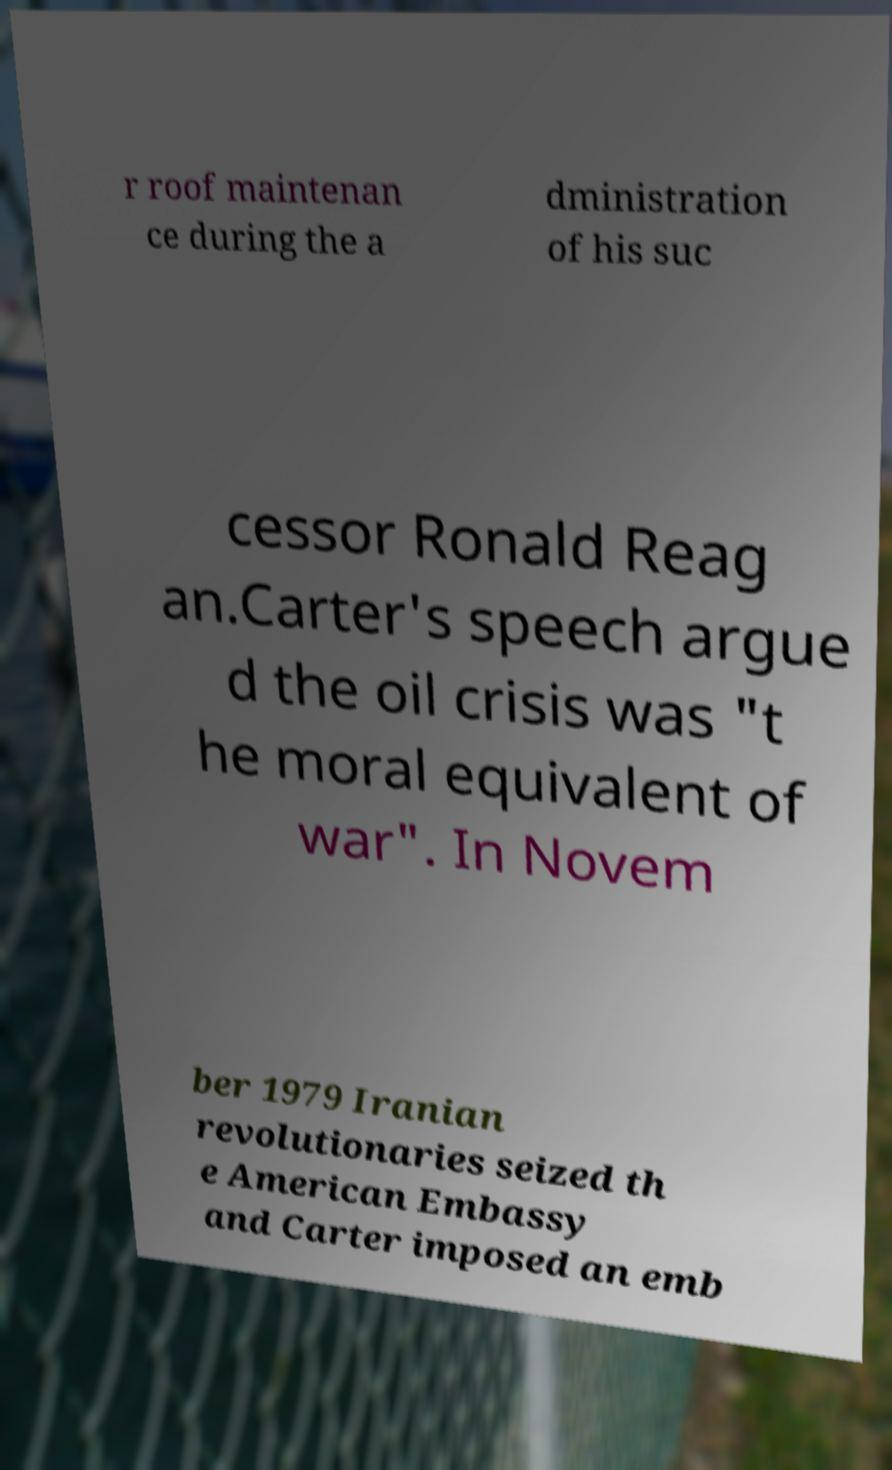Can you accurately transcribe the text from the provided image for me? r roof maintenan ce during the a dministration of his suc cessor Ronald Reag an.Carter's speech argue d the oil crisis was "t he moral equivalent of war". In Novem ber 1979 Iranian revolutionaries seized th e American Embassy and Carter imposed an emb 